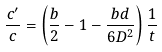<formula> <loc_0><loc_0><loc_500><loc_500>\frac { c ^ { \prime } } { c } = \left ( \frac { b } { 2 } - 1 - \frac { b d } { 6 D ^ { 2 } } \right ) \frac { 1 } { t }</formula> 